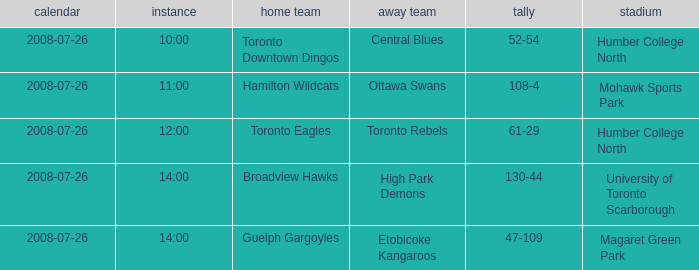With the Ground of Humber College North at 12:00, what was the Away? Toronto Rebels. Could you parse the entire table? {'header': ['calendar', 'instance', 'home team', 'away team', 'tally', 'stadium'], 'rows': [['2008-07-26', '10:00', 'Toronto Downtown Dingos', 'Central Blues', '52-54', 'Humber College North'], ['2008-07-26', '11:00', 'Hamilton Wildcats', 'Ottawa Swans', '108-4', 'Mohawk Sports Park'], ['2008-07-26', '12:00', 'Toronto Eagles', 'Toronto Rebels', '61-29', 'Humber College North'], ['2008-07-26', '14:00', 'Broadview Hawks', 'High Park Demons', '130-44', 'University of Toronto Scarborough'], ['2008-07-26', '14:00', 'Guelph Gargoyles', 'Etobicoke Kangaroos', '47-109', 'Magaret Green Park']]} 